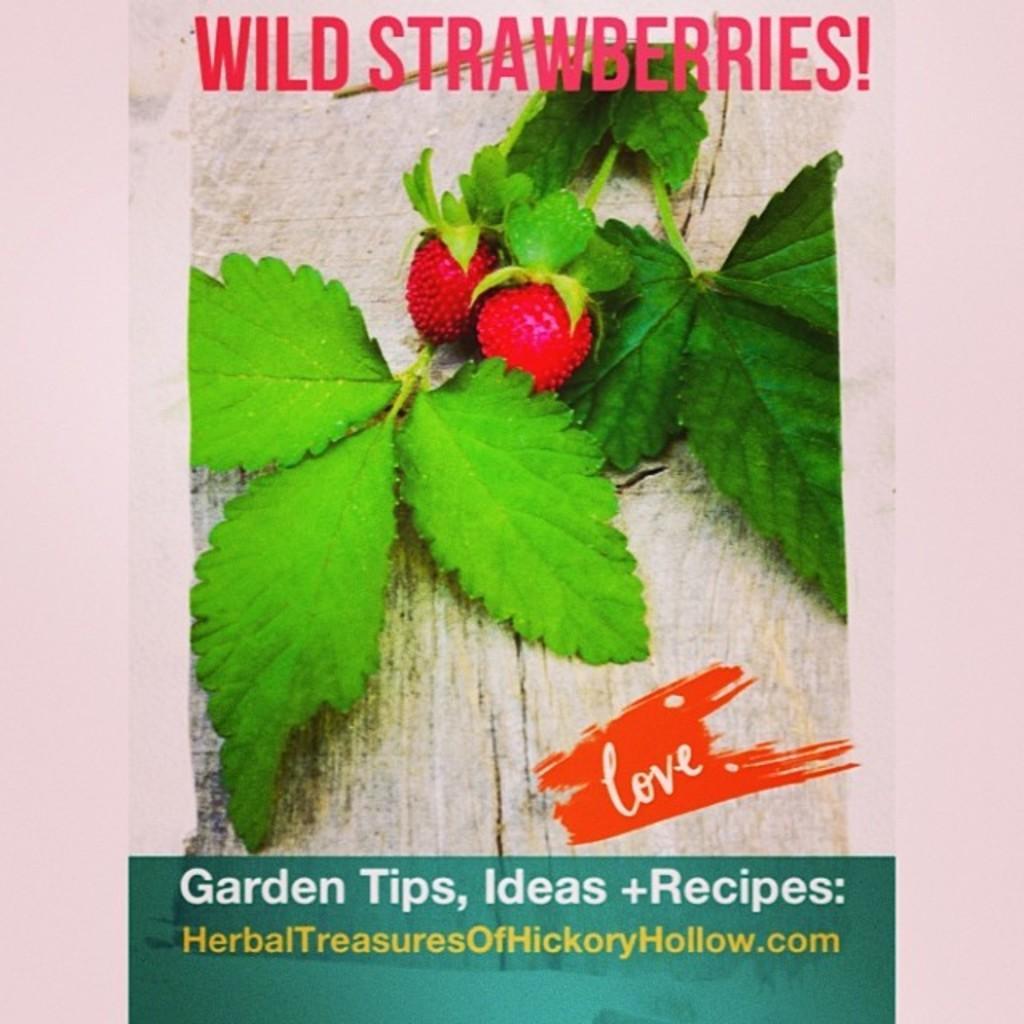Describe this image in one or two sentences. This is a poster. We can see some text on top and at the bottom of the picture. In this poster, we can see a few leaves and fruits. 